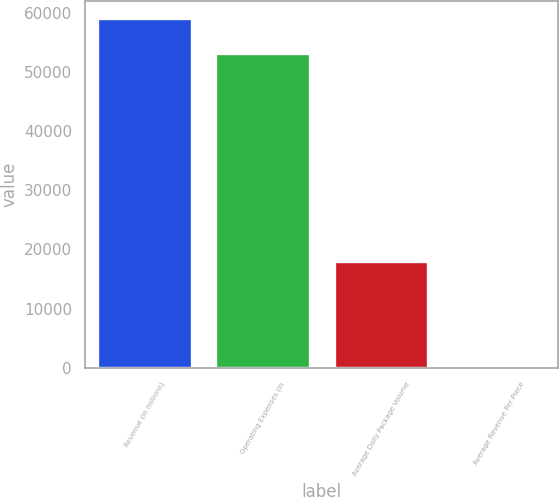Convert chart. <chart><loc_0><loc_0><loc_500><loc_500><bar_chart><fcel>Revenue (in millions)<fcel>Operating Expenses (in<fcel>Average Daily Package Volume<fcel>Average Revenue Per Piece<nl><fcel>59086.1<fcel>53264<fcel>18016<fcel>10.58<nl></chart> 